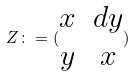<formula> <loc_0><loc_0><loc_500><loc_500>Z \colon = ( \begin{matrix} x & d y \\ y & x \end{matrix} )</formula> 